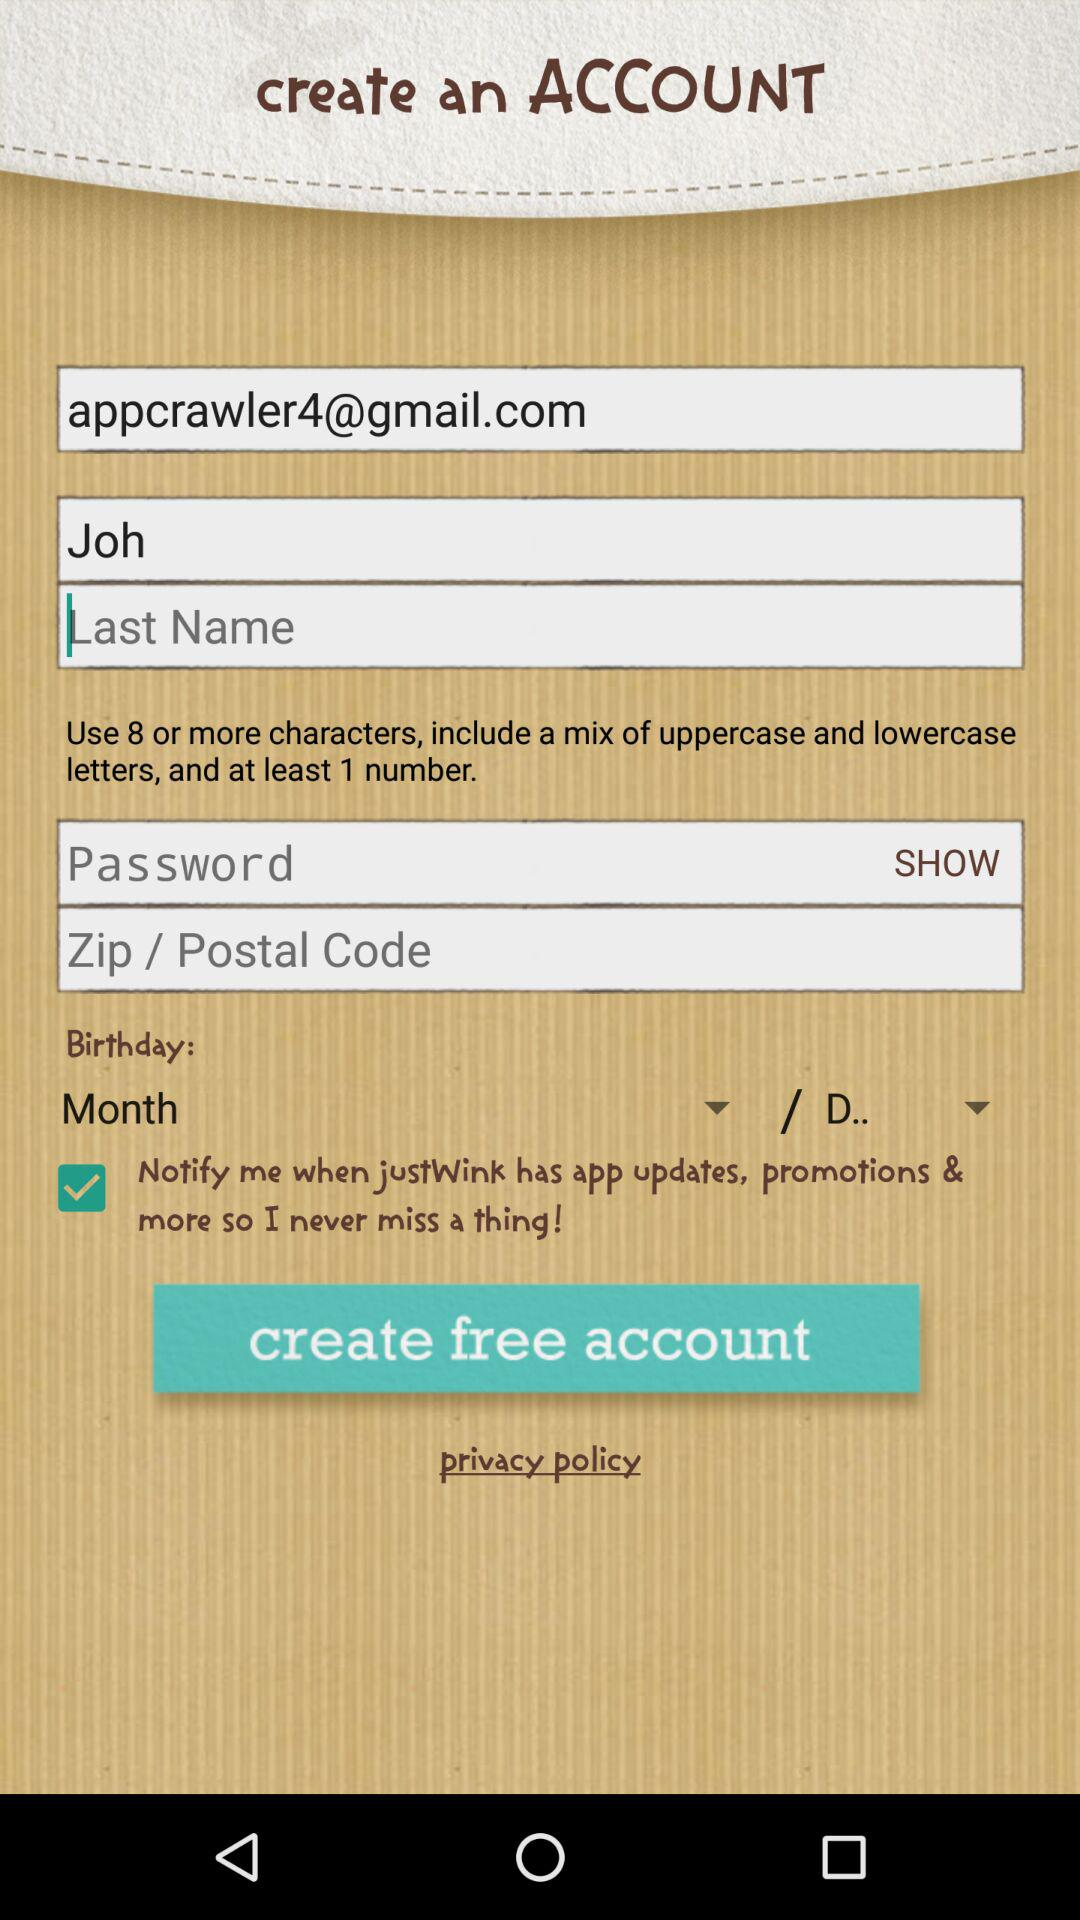What is the user name? The user name is Joh. 